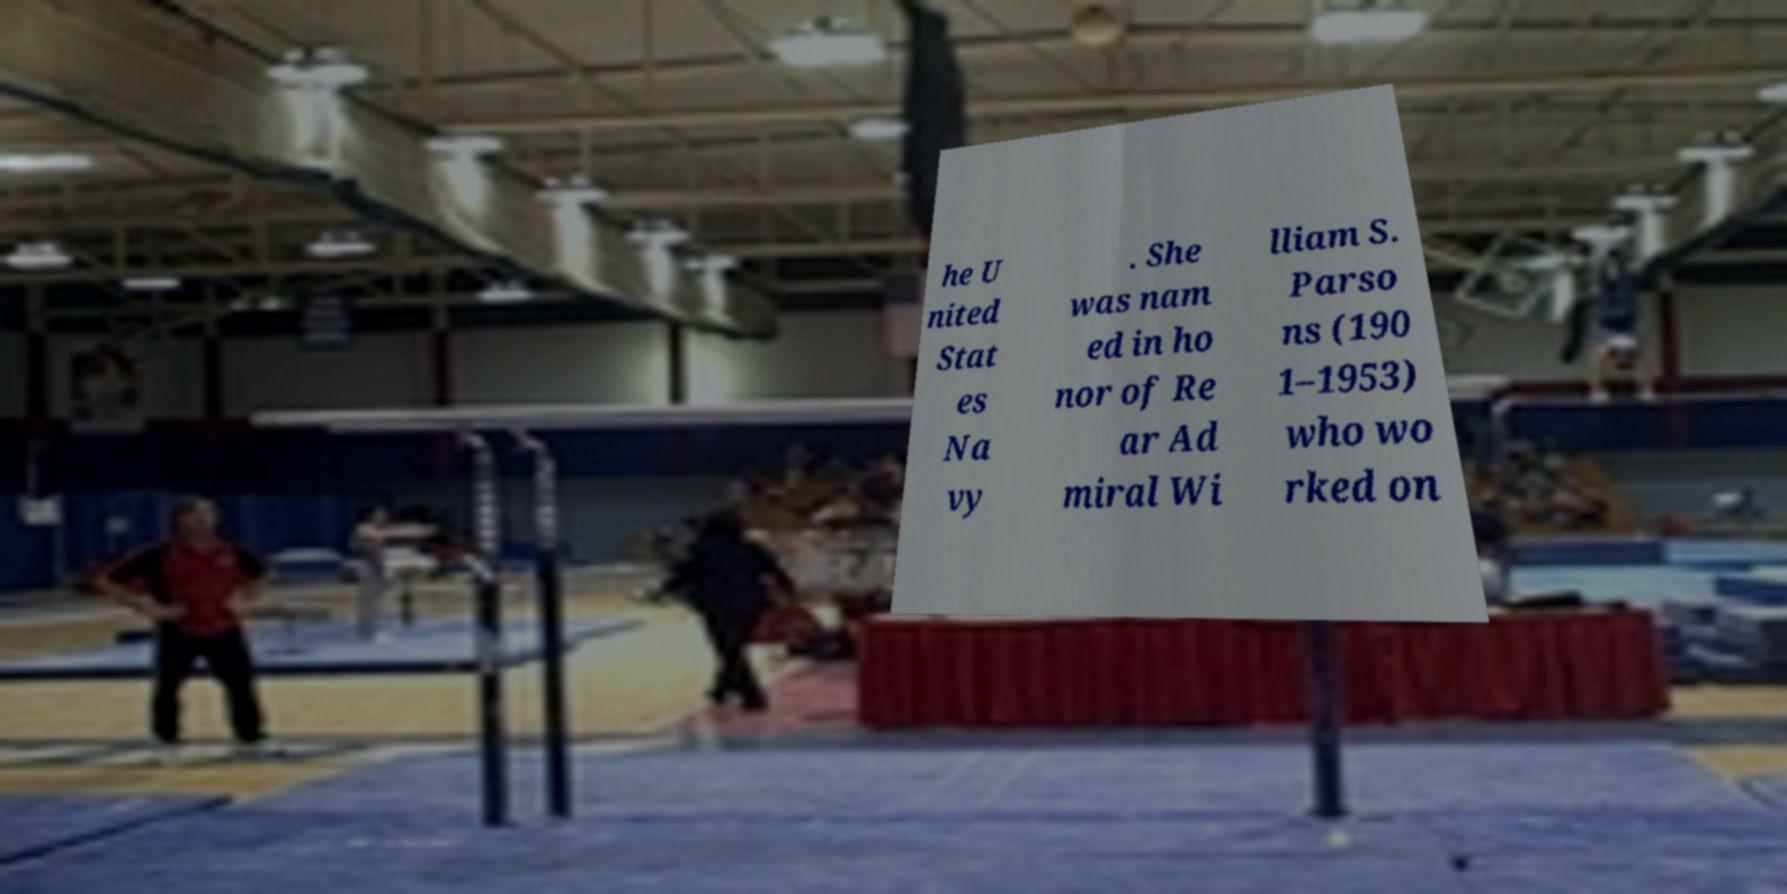Can you accurately transcribe the text from the provided image for me? he U nited Stat es Na vy . She was nam ed in ho nor of Re ar Ad miral Wi lliam S. Parso ns (190 1–1953) who wo rked on 